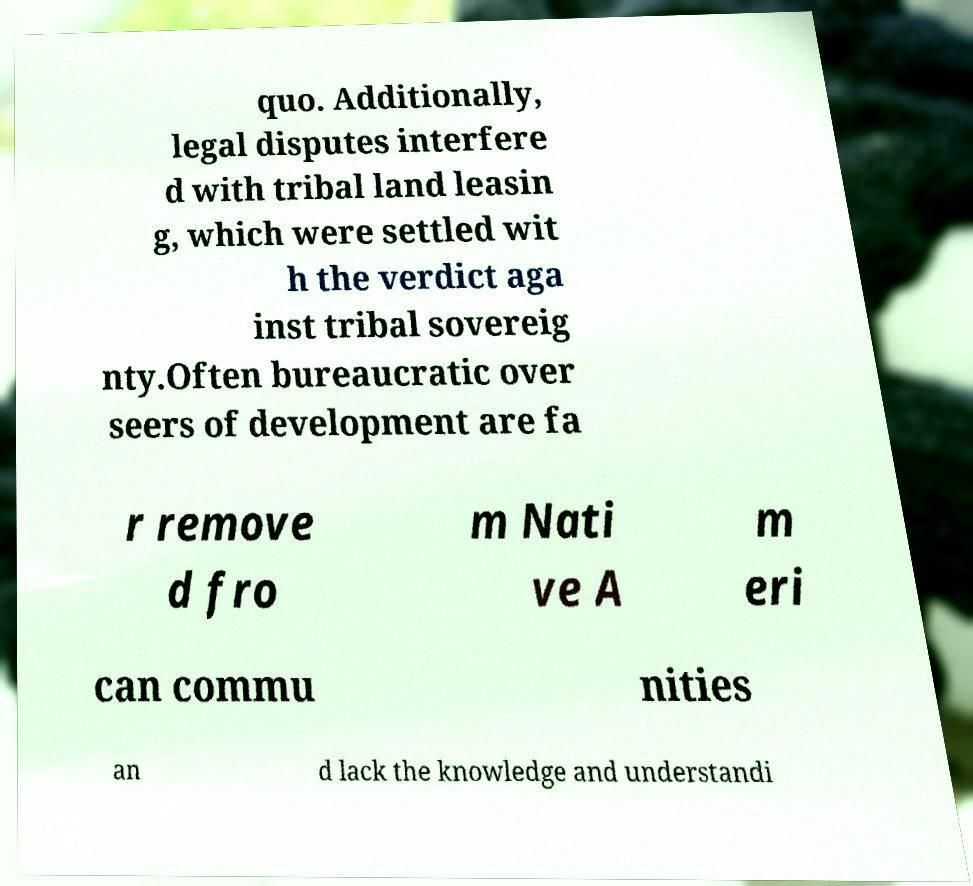For documentation purposes, I need the text within this image transcribed. Could you provide that? quo. Additionally, legal disputes interfere d with tribal land leasin g, which were settled wit h the verdict aga inst tribal sovereig nty.Often bureaucratic over seers of development are fa r remove d fro m Nati ve A m eri can commu nities an d lack the knowledge and understandi 